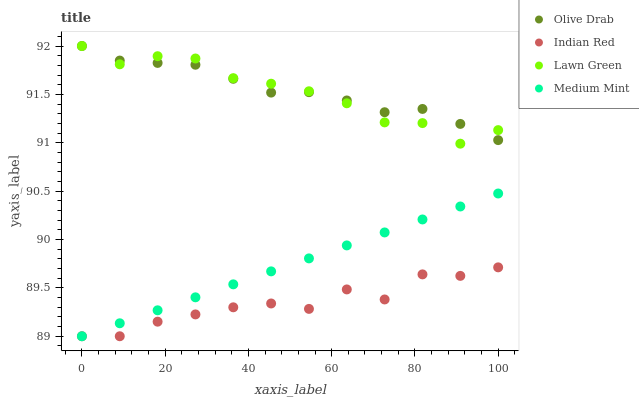Does Indian Red have the minimum area under the curve?
Answer yes or no. Yes. Does Olive Drab have the maximum area under the curve?
Answer yes or no. Yes. Does Lawn Green have the minimum area under the curve?
Answer yes or no. No. Does Lawn Green have the maximum area under the curve?
Answer yes or no. No. Is Medium Mint the smoothest?
Answer yes or no. Yes. Is Indian Red the roughest?
Answer yes or no. Yes. Is Lawn Green the smoothest?
Answer yes or no. No. Is Lawn Green the roughest?
Answer yes or no. No. Does Medium Mint have the lowest value?
Answer yes or no. Yes. Does Lawn Green have the lowest value?
Answer yes or no. No. Does Olive Drab have the highest value?
Answer yes or no. Yes. Does Indian Red have the highest value?
Answer yes or no. No. Is Medium Mint less than Olive Drab?
Answer yes or no. Yes. Is Olive Drab greater than Medium Mint?
Answer yes or no. Yes. Does Indian Red intersect Medium Mint?
Answer yes or no. Yes. Is Indian Red less than Medium Mint?
Answer yes or no. No. Is Indian Red greater than Medium Mint?
Answer yes or no. No. Does Medium Mint intersect Olive Drab?
Answer yes or no. No. 